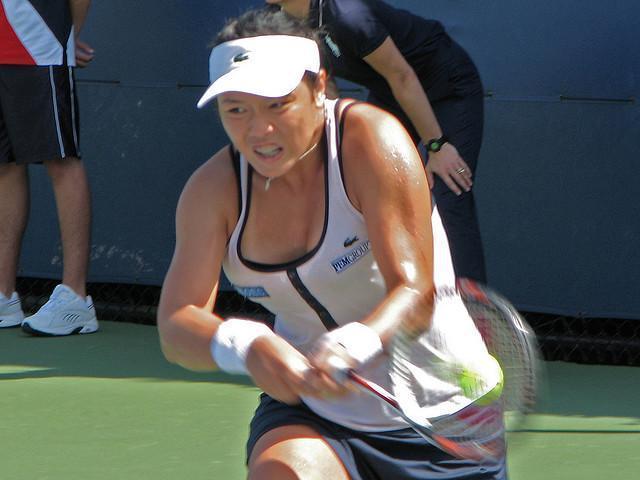How many people are there?
Give a very brief answer. 3. 